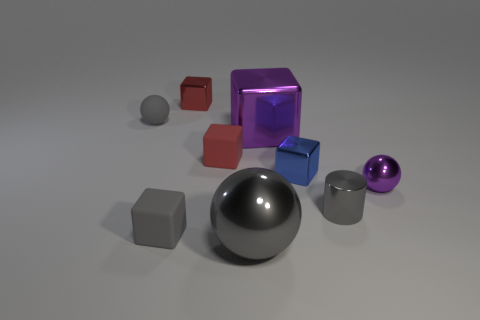There is another tiny shiny thing that is the same shape as the blue metallic object; what is its color?
Make the answer very short. Red. What is the shape of the small purple thing?
Your answer should be compact. Sphere. How many things are gray cubes or large purple things?
Your answer should be compact. 2. Does the tiny metal cube in front of the red metallic block have the same color as the small metallic thing that is on the left side of the small red matte block?
Offer a very short reply. No. What number of other things are the same shape as the big purple object?
Your answer should be compact. 4. Is there a big blue thing?
Your answer should be compact. No. What number of things are small matte things or tiny metallic things that are behind the blue thing?
Make the answer very short. 4. There is a red thing in front of the purple block; is its size the same as the large shiny cube?
Give a very brief answer. No. What number of other objects are the same size as the matte sphere?
Provide a succinct answer. 6. The small metallic ball has what color?
Keep it short and to the point. Purple. 